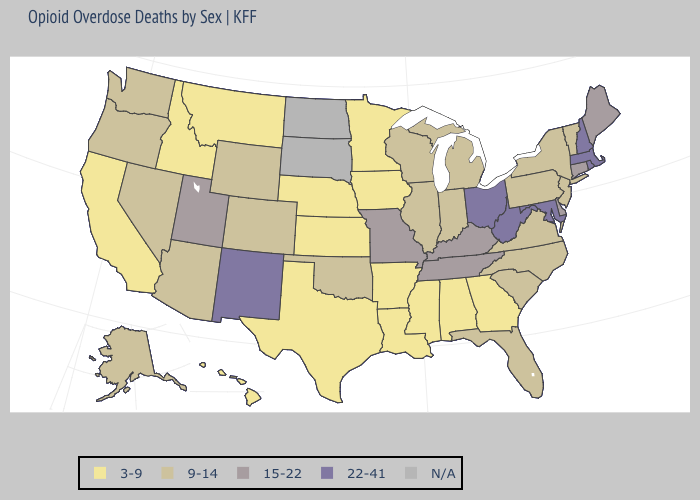What is the value of Montana?
Concise answer only. 3-9. Among the states that border Illinois , which have the highest value?
Give a very brief answer. Kentucky, Missouri. Which states have the lowest value in the USA?
Write a very short answer. Alabama, Arkansas, California, Georgia, Hawaii, Idaho, Iowa, Kansas, Louisiana, Minnesota, Mississippi, Montana, Nebraska, Texas. Is the legend a continuous bar?
Concise answer only. No. Does the map have missing data?
Quick response, please. Yes. Which states have the highest value in the USA?
Give a very brief answer. Maryland, Massachusetts, New Hampshire, New Mexico, Ohio, Rhode Island, West Virginia. Name the states that have a value in the range 22-41?
Give a very brief answer. Maryland, Massachusetts, New Hampshire, New Mexico, Ohio, Rhode Island, West Virginia. Among the states that border Missouri , does Iowa have the lowest value?
Keep it brief. Yes. Among the states that border Maryland , does Pennsylvania have the highest value?
Be succinct. No. Among the states that border Massachusetts , which have the lowest value?
Give a very brief answer. New York, Vermont. What is the value of Wyoming?
Be succinct. 9-14. Does Colorado have the lowest value in the USA?
Give a very brief answer. No. How many symbols are there in the legend?
Write a very short answer. 5. Name the states that have a value in the range 9-14?
Concise answer only. Alaska, Arizona, Colorado, Florida, Illinois, Indiana, Michigan, Nevada, New Jersey, New York, North Carolina, Oklahoma, Oregon, Pennsylvania, South Carolina, Vermont, Virginia, Washington, Wisconsin, Wyoming. 